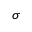<formula> <loc_0><loc_0><loc_500><loc_500>\sigma</formula> 